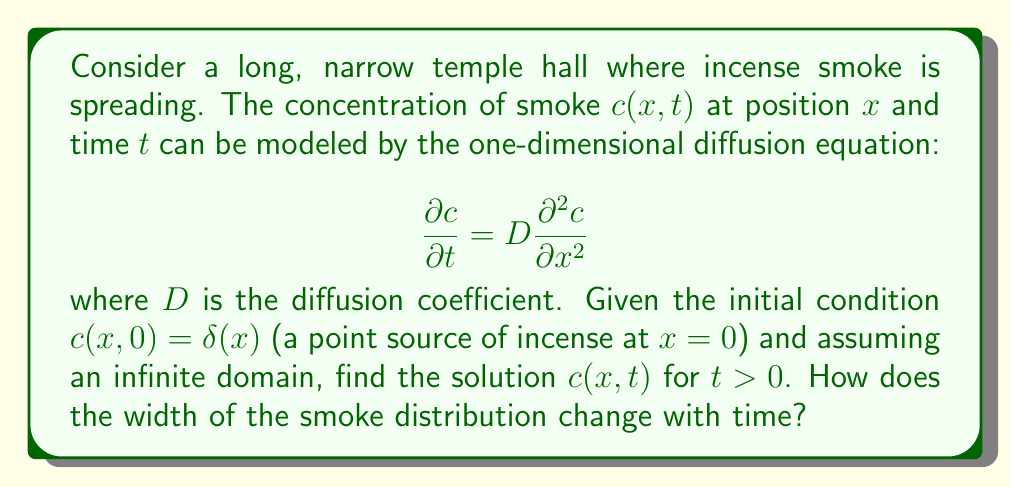Solve this math problem. To solve this problem, we'll follow these steps:

1) The given equation is the one-dimensional diffusion equation with initial condition $c(x,0) = \delta(x)$, where $\delta(x)$ is the Dirac delta function.

2) The solution to this equation with these conditions is known as the fundamental solution or Green's function. It is given by:

   $$c(x,t) = \frac{1}{\sqrt{4\pi Dt}} \exp\left(-\frac{x^2}{4Dt}\right)$$

3) To derive this, one could use Fourier transforms or similarity methods, but that's beyond the scope of this explanation.

4) This solution represents a Gaussian distribution that spreads out over time. The peak concentration decreases as $1/\sqrt{t}$, while the width of the distribution increases as $\sqrt{t}$.

5) To quantify the width of the distribution, we can use the standard deviation $\sigma$ of the Gaussian. For this solution:

   $$\sigma = \sqrt{2Dt}$$

6) This shows that the width of the smoke distribution increases as the square root of time.

This solution provides insight into how incense smoke would spread in a long, narrow temple hall. Initially concentrated at a point, the smoke gradually spreads out, with its concentration peak decreasing and its distribution widening over time.
Answer: The solution to the diffusion equation for incense smoke spreading from a point source is:

$$c(x,t) = \frac{1}{\sqrt{4\pi Dt}} \exp\left(-\frac{x^2}{4Dt}\right)$$

The width of the smoke distribution, characterized by its standard deviation, increases as the square root of time:

$$\sigma = \sqrt{2Dt}$$ 